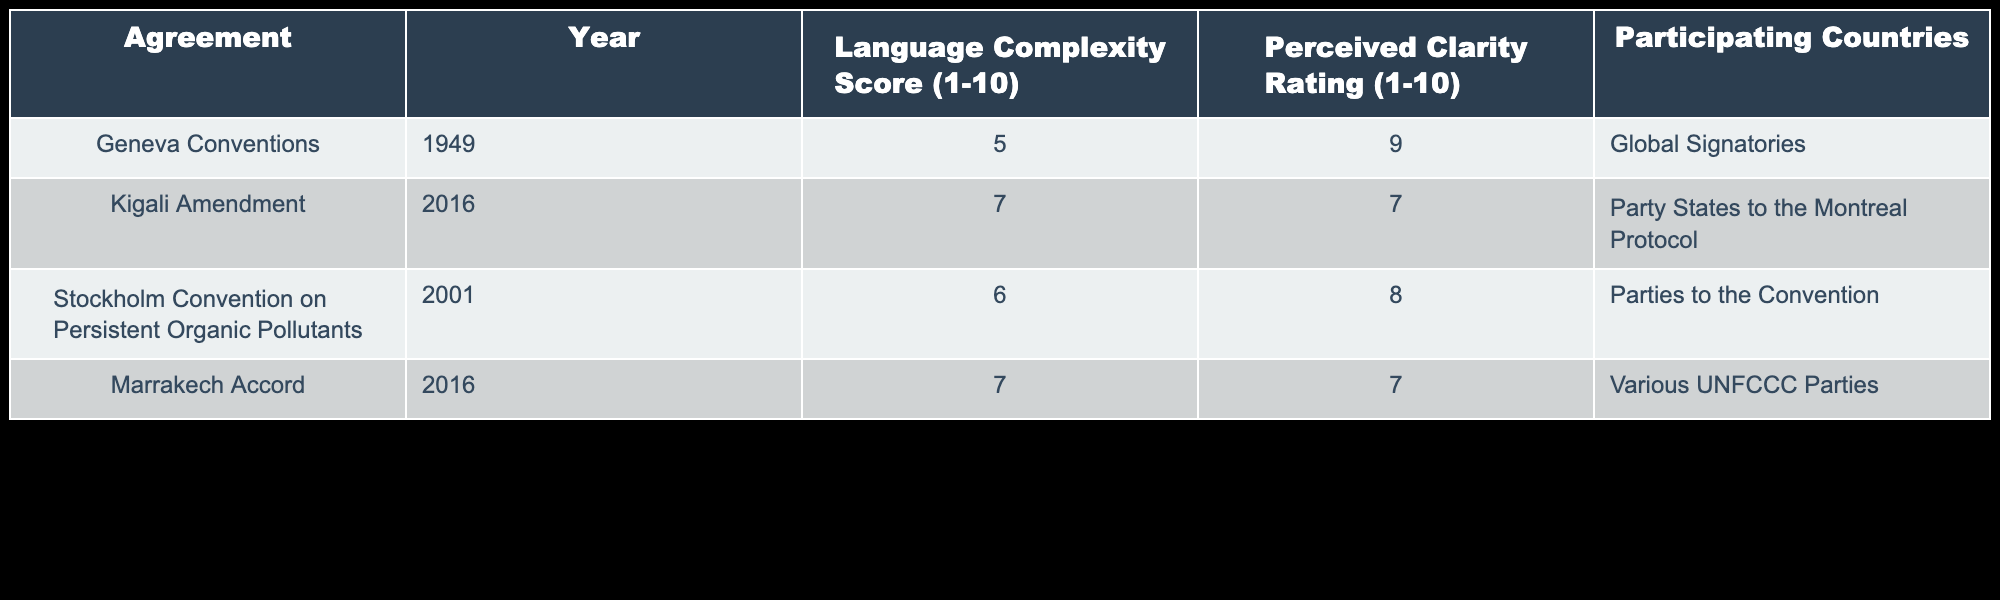What is the Language Complexity Score of the Geneva Conventions? The Language Complexity Score for the Geneva Conventions is listed in the table as 5. This information can be directly found in the appropriate row under the specified column.
Answer: 5 What is the Perceived Clarity Rating of the Marrakech Accord? Looking at the row for the Marrakech Accord, the Perceived Clarity Rating is 7. This value is obtained from the corresponding cell in the table.
Answer: 7 How many participating countries are involved in the Stockholm Convention? The number of participating countries in the Stockholm Convention is stated as "Parties to the Convention." While it may not be a quantifiable number, the description indicates a group rather than a specific count.
Answer: Parties to the Convention Is there a correlation between higher Language Complexity Scores and lower Perceived Clarity Ratings in the agreements presented? Analyzing the values from the table, the Geneva Conventions have a Language Complexity Score of 5 and a Perceived Clarity Rating of 9. The Kigali Amendment, on the other hand, has a higher Complexity Score of 7 but a lower Clarity Rating of 7. Therefore, while there is a suggestion of complexity affecting clarity, additional analysis would be needed for a definitive correlation.
Answer: Yes, it suggests correlation What is the average Language Complexity Score of the agreements listed in the table? To find the average Language Complexity Score, the values from the table are summed: 5 (Geneva) + 7 (Kigali) + 6 (Stockholm) + 7 (Marrakech) = 25. Since there are 4 agreements, the average is calculated as 25/4 = 6.25.
Answer: 6.25 Do the agreements with higher complexity scores generally have a higher perceived clarity rating? By examining the scores from the table, the agreements show mixed results. For example, the Geneva Conventions (5 complexity, 9 clarity) and the Kigali Amendment (7 complexity, 7 clarity). This indicates that higher complexity does not necessarily lead to clearer messages, contrasting complexity and clarity in these instances.
Answer: No, they do not show a consistent pattern What is the difference between the highest and lowest Perceived Clarity Ratings in the table? The highest Perceived Clarity Rating is 9 (Geneva Conventions), while the lowest is 7 (Kigali Amendment and Marrakech Accord). The difference is calculated as 9 - 7 = 2.
Answer: 2 Which agreement has the highest Language Complexity Score, and what is the corresponding Perceived Clarity Rating? The agreement with the highest Language Complexity Score is the Kigali Amendment with a score of 7. The corresponding Perceived Clarity Rating for this agreement is also 7. Both values can be found in the same row.
Answer: Kigali Amendment, 7 Does the Stockholm Convention have a higher or lower Perceived Clarity Rating than the Kigali Amendment? The Stockholm Convention has a Perceived Clarity Rating of 8, while the Kigali Amendment has a rating of 7. Therefore, the Stockholm Convention has a higher rating than the Kigali Amendment.
Answer: Higher 